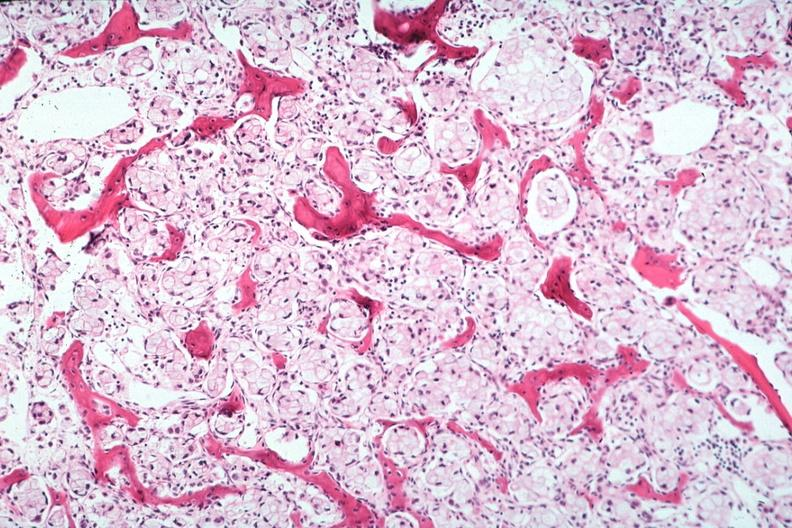s joints present?
Answer the question using a single word or phrase. Yes 